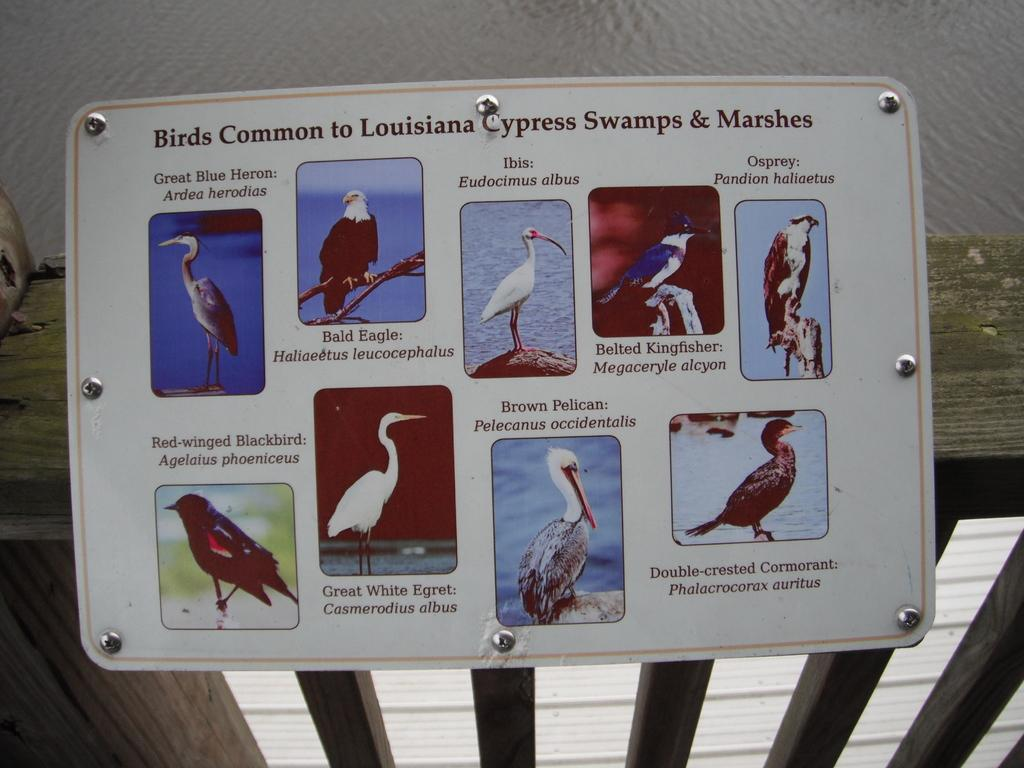What is the main object in the image? There is a white color board in the image. How is the color board attached to the wooden railing? The board is fixed to a wooden railing. What can be seen on the color board? There are different types of birds on the board. What can be seen in the background of the image? There is water visible in the background of the image. What type of meat is being served on the wooden railing in the image? There is no meat visible in the image; the main object is a white color board with birds on it. 